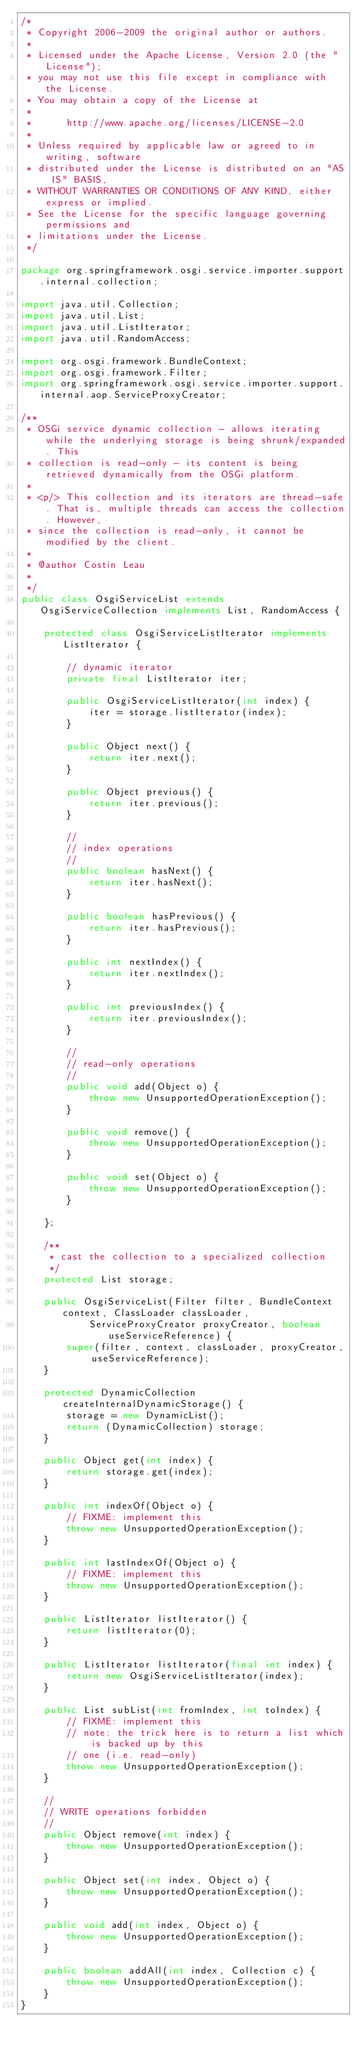<code> <loc_0><loc_0><loc_500><loc_500><_Java_>/*
 * Copyright 2006-2009 the original author or authors.
 * 
 * Licensed under the Apache License, Version 2.0 (the "License");
 * you may not use this file except in compliance with the License.
 * You may obtain a copy of the License at
 * 
 *      http://www.apache.org/licenses/LICENSE-2.0
 * 
 * Unless required by applicable law or agreed to in writing, software
 * distributed under the License is distributed on an "AS IS" BASIS,
 * WITHOUT WARRANTIES OR CONDITIONS OF ANY KIND, either express or implied.
 * See the License for the specific language governing permissions and
 * limitations under the License.
 */

package org.springframework.osgi.service.importer.support.internal.collection;

import java.util.Collection;
import java.util.List;
import java.util.ListIterator;
import java.util.RandomAccess;

import org.osgi.framework.BundleContext;
import org.osgi.framework.Filter;
import org.springframework.osgi.service.importer.support.internal.aop.ServiceProxyCreator;

/**
 * OSGi service dynamic collection - allows iterating while the underlying storage is being shrunk/expanded. This
 * collection is read-only - its content is being retrieved dynamically from the OSGi platform.
 * 
 * <p/> This collection and its iterators are thread-safe. That is, multiple threads can access the collection. However,
 * since the collection is read-only, it cannot be modified by the client.
 * 
 * @author Costin Leau
 * 
 */
public class OsgiServiceList extends OsgiServiceCollection implements List, RandomAccess {

	protected class OsgiServiceListIterator implements ListIterator {

		// dynamic iterator
		private final ListIterator iter;

		public OsgiServiceListIterator(int index) {
			iter = storage.listIterator(index);
		}

		public Object next() {
			return iter.next();
		}

		public Object previous() {
			return iter.previous();
		}

		//
		// index operations
		//
		public boolean hasNext() {
			return iter.hasNext();
		}

		public boolean hasPrevious() {
			return iter.hasPrevious();
		}

		public int nextIndex() {
			return iter.nextIndex();
		}

		public int previousIndex() {
			return iter.previousIndex();
		}

		//
		// read-only operations
		//
		public void add(Object o) {
			throw new UnsupportedOperationException();
		}

		public void remove() {
			throw new UnsupportedOperationException();
		}

		public void set(Object o) {
			throw new UnsupportedOperationException();
		}

	};

	/**
	 * cast the collection to a specialized collection
	 */
	protected List storage;

	public OsgiServiceList(Filter filter, BundleContext context, ClassLoader classLoader,
			ServiceProxyCreator proxyCreator, boolean useServiceReference) {
		super(filter, context, classLoader, proxyCreator, useServiceReference);
	}

	protected DynamicCollection createInternalDynamicStorage() {
		storage = new DynamicList();
		return (DynamicCollection) storage;
	}

	public Object get(int index) {
		return storage.get(index);
	}

	public int indexOf(Object o) {
		// FIXME: implement this
		throw new UnsupportedOperationException();
	}

	public int lastIndexOf(Object o) {
		// FIXME: implement this
		throw new UnsupportedOperationException();
	}

	public ListIterator listIterator() {
		return listIterator(0);
	}

	public ListIterator listIterator(final int index) {
		return new OsgiServiceListIterator(index);
	}

	public List subList(int fromIndex, int toIndex) {
		// FIXME: implement this
		// note: the trick here is to return a list which is backed up by this
		// one (i.e. read-only)
		throw new UnsupportedOperationException();
	}

	//
	// WRITE operations forbidden
	//
	public Object remove(int index) {
		throw new UnsupportedOperationException();
	}

	public Object set(int index, Object o) {
		throw new UnsupportedOperationException();
	}

	public void add(int index, Object o) {
		throw new UnsupportedOperationException();
	}

	public boolean addAll(int index, Collection c) {
		throw new UnsupportedOperationException();
	}
}</code> 